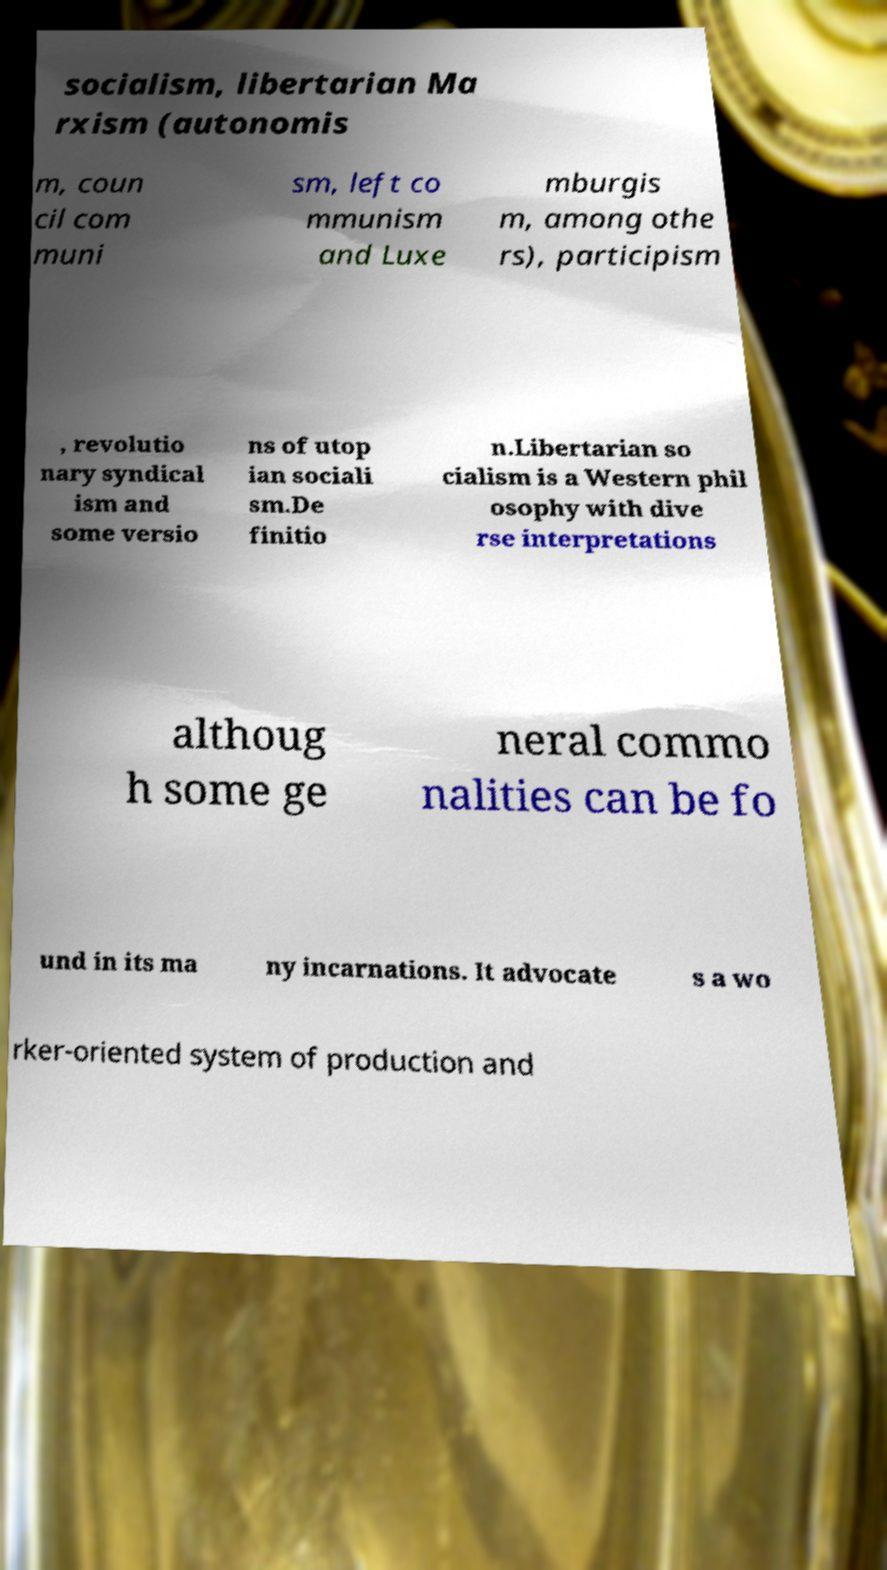There's text embedded in this image that I need extracted. Can you transcribe it verbatim? socialism, libertarian Ma rxism (autonomis m, coun cil com muni sm, left co mmunism and Luxe mburgis m, among othe rs), participism , revolutio nary syndical ism and some versio ns of utop ian sociali sm.De finitio n.Libertarian so cialism is a Western phil osophy with dive rse interpretations althoug h some ge neral commo nalities can be fo und in its ma ny incarnations. It advocate s a wo rker-oriented system of production and 